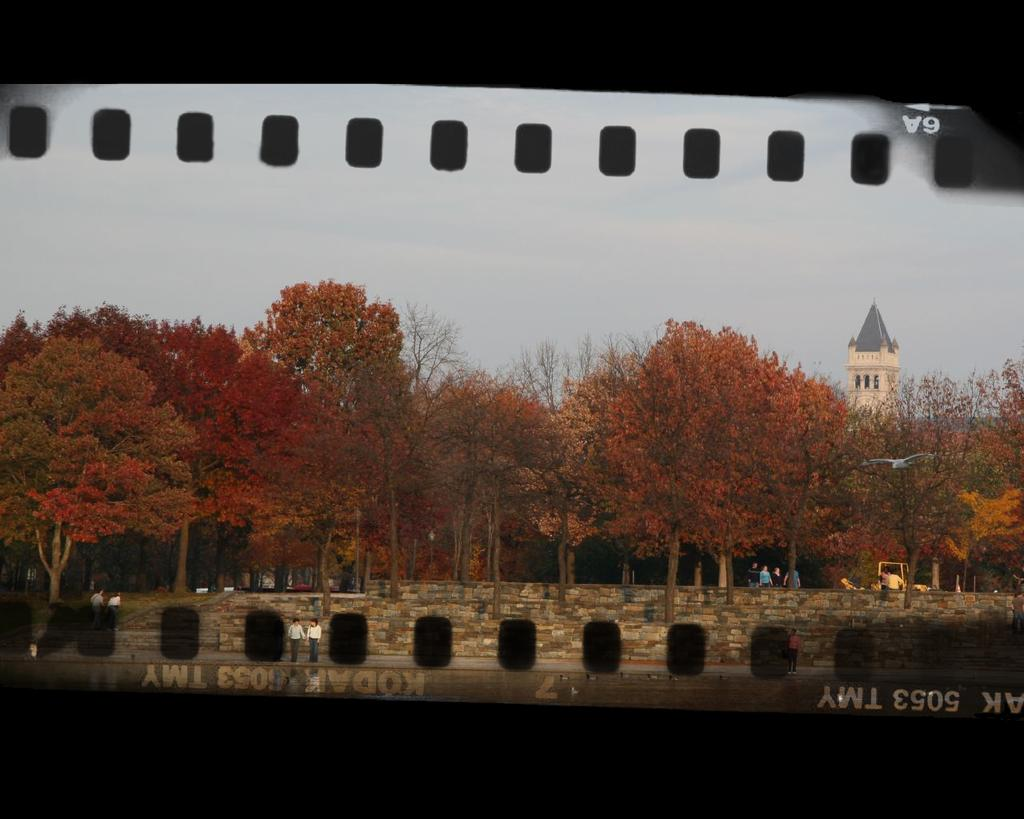Provide a one-sentence caption for the provided image. A strip of film negative has the code 5053 TMY on it. 